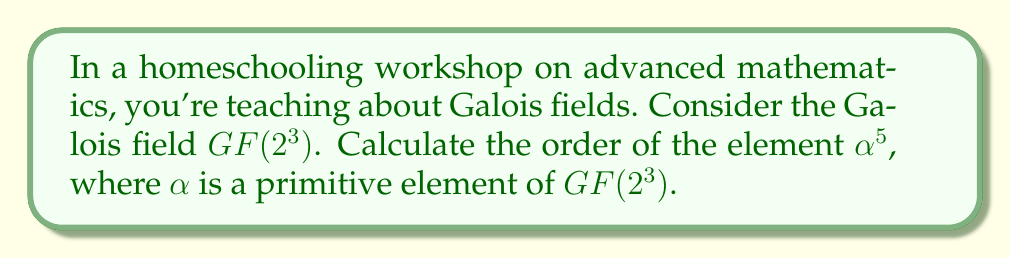Show me your answer to this math problem. Let's approach this step-by-step:

1) First, recall that in $GF(2^3)$, the order of any non-zero element divides $2^3 - 1 = 7$.

2) The possible orders are therefore 1 and 7.

3) $\alpha$ is a primitive element, which means it generates all non-zero elements of the field. Thus, $\alpha$ has order 7.

4) Now, let's consider $\alpha^5$:
   
   $(\alpha^5)^7 = \alpha^{35} = (\alpha^7)^5 = 1^5 = 1$

5) This shows that the order of $\alpha^5$ divides 7.

6) To check if the order is 1, we need to verify if $\alpha^5 = 1$:
   
   If $\alpha^5 = 1$, then $\alpha^7 = \alpha^2$, which contradicts $\alpha^7 = 1$.

7) Therefore, $\alpha^5 \neq 1$, so its order cannot be 1.

8) The only remaining possibility is that the order of $\alpha^5$ is 7.
Answer: 7 